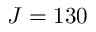<formula> <loc_0><loc_0><loc_500><loc_500>J = 1 3 0</formula> 